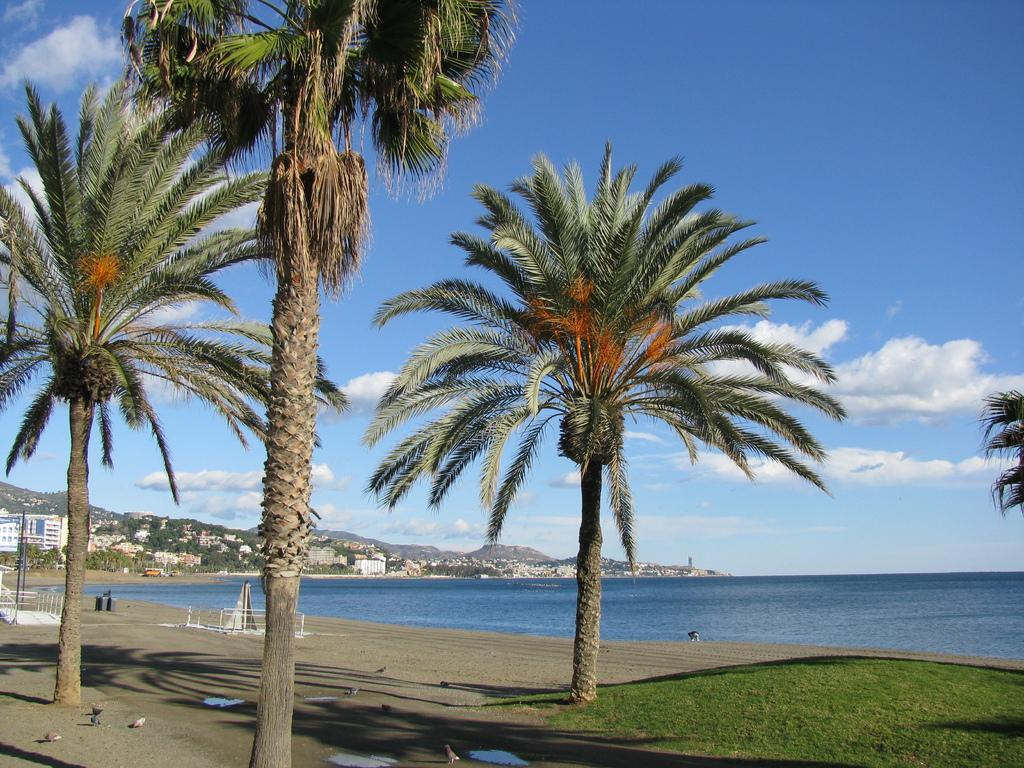What type of natural elements can be seen in the image? The image contains trees. What type of location might the image depict? The image appears to be taken near a beach. What structures or landmarks are visible on the left side of the image? There are mountains and buildings visible on the left side of the image. What can be seen in the sky at the top of the image? There are clouds in the sky at the top of the image. Who won the competition between the doctor and the smile in the image? There is no competition, doctor, or smile present in the image. 